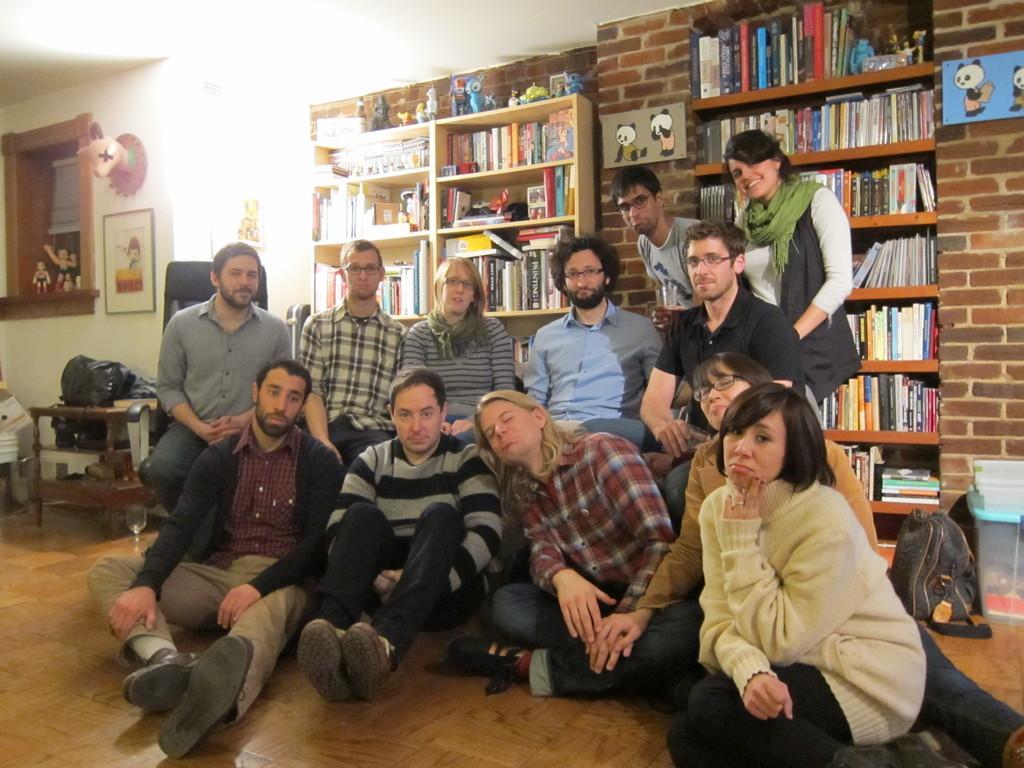How would you summarize this image in a sentence or two? In front of the image there is a group of people sitting on the floor and the sofa and there are two people standing, behind them there are books on the shelves and there are cartoon posters on the wall, behind them there are some objects on the floor and there are photo frames and some objects on the wall and dolls in a window. 